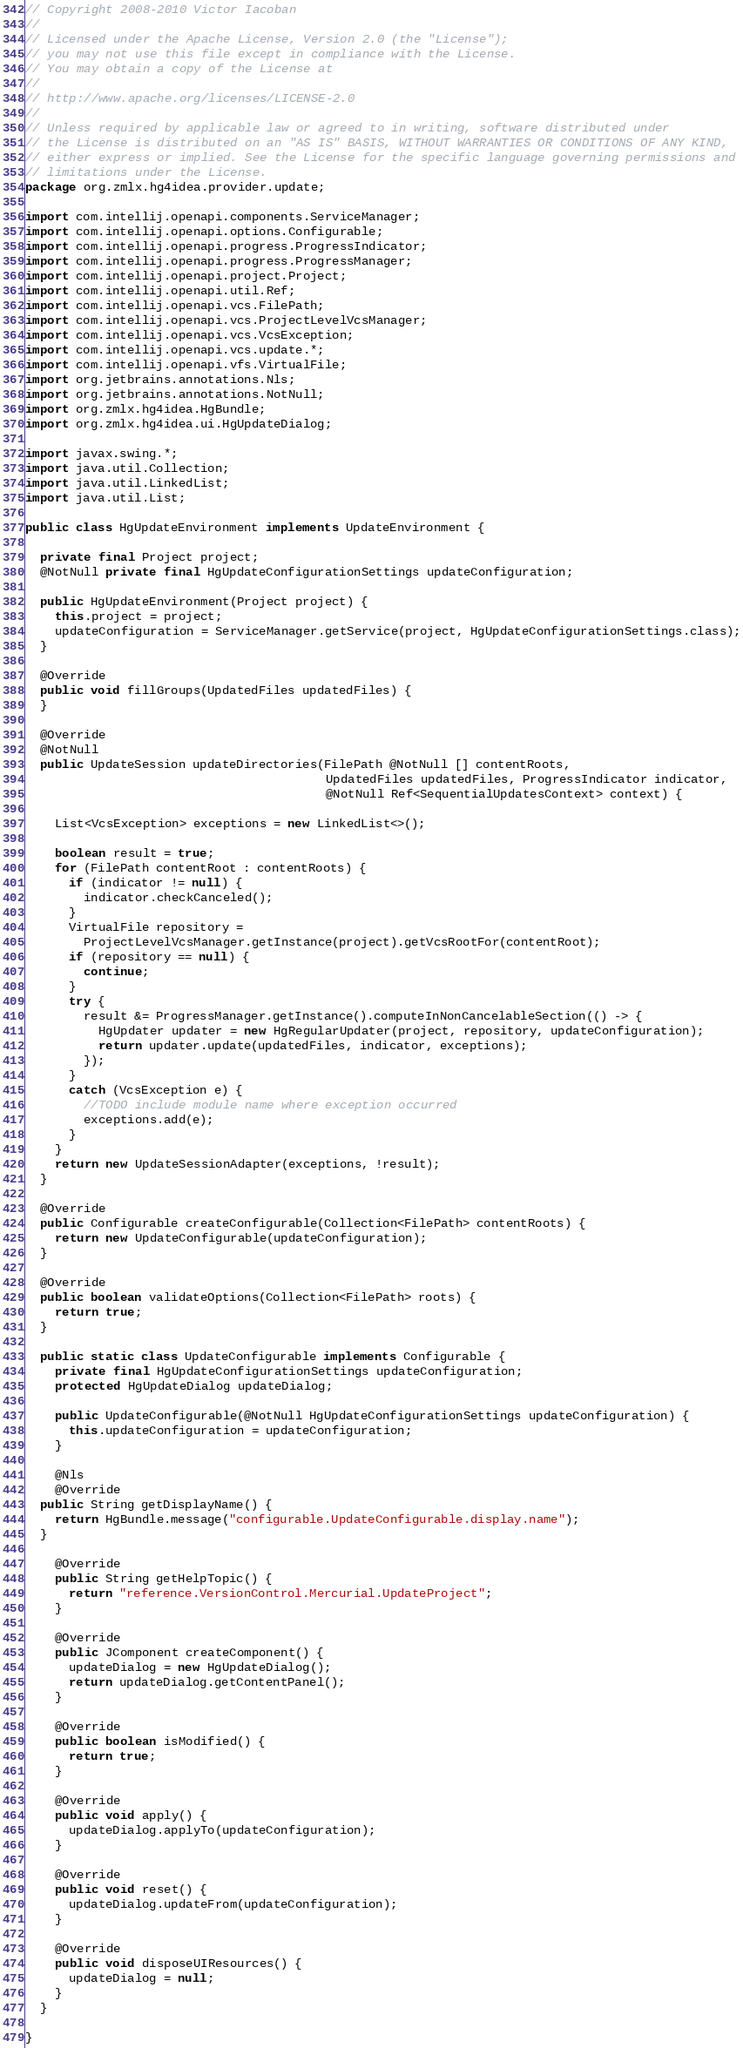<code> <loc_0><loc_0><loc_500><loc_500><_Java_>// Copyright 2008-2010 Victor Iacoban
//
// Licensed under the Apache License, Version 2.0 (the "License");
// you may not use this file except in compliance with the License.
// You may obtain a copy of the License at
//
// http://www.apache.org/licenses/LICENSE-2.0
//
// Unless required by applicable law or agreed to in writing, software distributed under
// the License is distributed on an "AS IS" BASIS, WITHOUT WARRANTIES OR CONDITIONS OF ANY KIND,
// either express or implied. See the License for the specific language governing permissions and
// limitations under the License.
package org.zmlx.hg4idea.provider.update;

import com.intellij.openapi.components.ServiceManager;
import com.intellij.openapi.options.Configurable;
import com.intellij.openapi.progress.ProgressIndicator;
import com.intellij.openapi.progress.ProgressManager;
import com.intellij.openapi.project.Project;
import com.intellij.openapi.util.Ref;
import com.intellij.openapi.vcs.FilePath;
import com.intellij.openapi.vcs.ProjectLevelVcsManager;
import com.intellij.openapi.vcs.VcsException;
import com.intellij.openapi.vcs.update.*;
import com.intellij.openapi.vfs.VirtualFile;
import org.jetbrains.annotations.Nls;
import org.jetbrains.annotations.NotNull;
import org.zmlx.hg4idea.HgBundle;
import org.zmlx.hg4idea.ui.HgUpdateDialog;

import javax.swing.*;
import java.util.Collection;
import java.util.LinkedList;
import java.util.List;

public class HgUpdateEnvironment implements UpdateEnvironment {

  private final Project project;
  @NotNull private final HgUpdateConfigurationSettings updateConfiguration;

  public HgUpdateEnvironment(Project project) {
    this.project = project;
    updateConfiguration = ServiceManager.getService(project, HgUpdateConfigurationSettings.class);
  }

  @Override
  public void fillGroups(UpdatedFiles updatedFiles) {
  }

  @Override
  @NotNull
  public UpdateSession updateDirectories(FilePath @NotNull [] contentRoots,
                                         UpdatedFiles updatedFiles, ProgressIndicator indicator,
                                         @NotNull Ref<SequentialUpdatesContext> context) {

    List<VcsException> exceptions = new LinkedList<>();

    boolean result = true;
    for (FilePath contentRoot : contentRoots) {
      if (indicator != null) {
        indicator.checkCanceled();
      }
      VirtualFile repository =
        ProjectLevelVcsManager.getInstance(project).getVcsRootFor(contentRoot);
      if (repository == null) {
        continue;
      }
      try {
        result &= ProgressManager.getInstance().computeInNonCancelableSection(() -> {
          HgUpdater updater = new HgRegularUpdater(project, repository, updateConfiguration);
          return updater.update(updatedFiles, indicator, exceptions);
        });
      }
      catch (VcsException e) {
        //TODO include module name where exception occurred
        exceptions.add(e);
      }
    }
    return new UpdateSessionAdapter(exceptions, !result);
  }

  @Override
  public Configurable createConfigurable(Collection<FilePath> contentRoots) {
    return new UpdateConfigurable(updateConfiguration);
  }

  @Override
  public boolean validateOptions(Collection<FilePath> roots) {
    return true;
  }

  public static class UpdateConfigurable implements Configurable {
    private final HgUpdateConfigurationSettings updateConfiguration;
    protected HgUpdateDialog updateDialog;

    public UpdateConfigurable(@NotNull HgUpdateConfigurationSettings updateConfiguration) {
      this.updateConfiguration = updateConfiguration;
    }

    @Nls
    @Override
  public String getDisplayName() {
    return HgBundle.message("configurable.UpdateConfigurable.display.name");
  }

    @Override
    public String getHelpTopic() {
      return "reference.VersionControl.Mercurial.UpdateProject";
    }

    @Override
    public JComponent createComponent() {
      updateDialog = new HgUpdateDialog();
      return updateDialog.getContentPanel();
    }

    @Override
    public boolean isModified() {
      return true;
    }

    @Override
    public void apply() {
      updateDialog.applyTo(updateConfiguration);
    }

    @Override
    public void reset() {
      updateDialog.updateFrom(updateConfiguration);
    }

    @Override
    public void disposeUIResources() {
      updateDialog = null;
    }
  }

}
</code> 